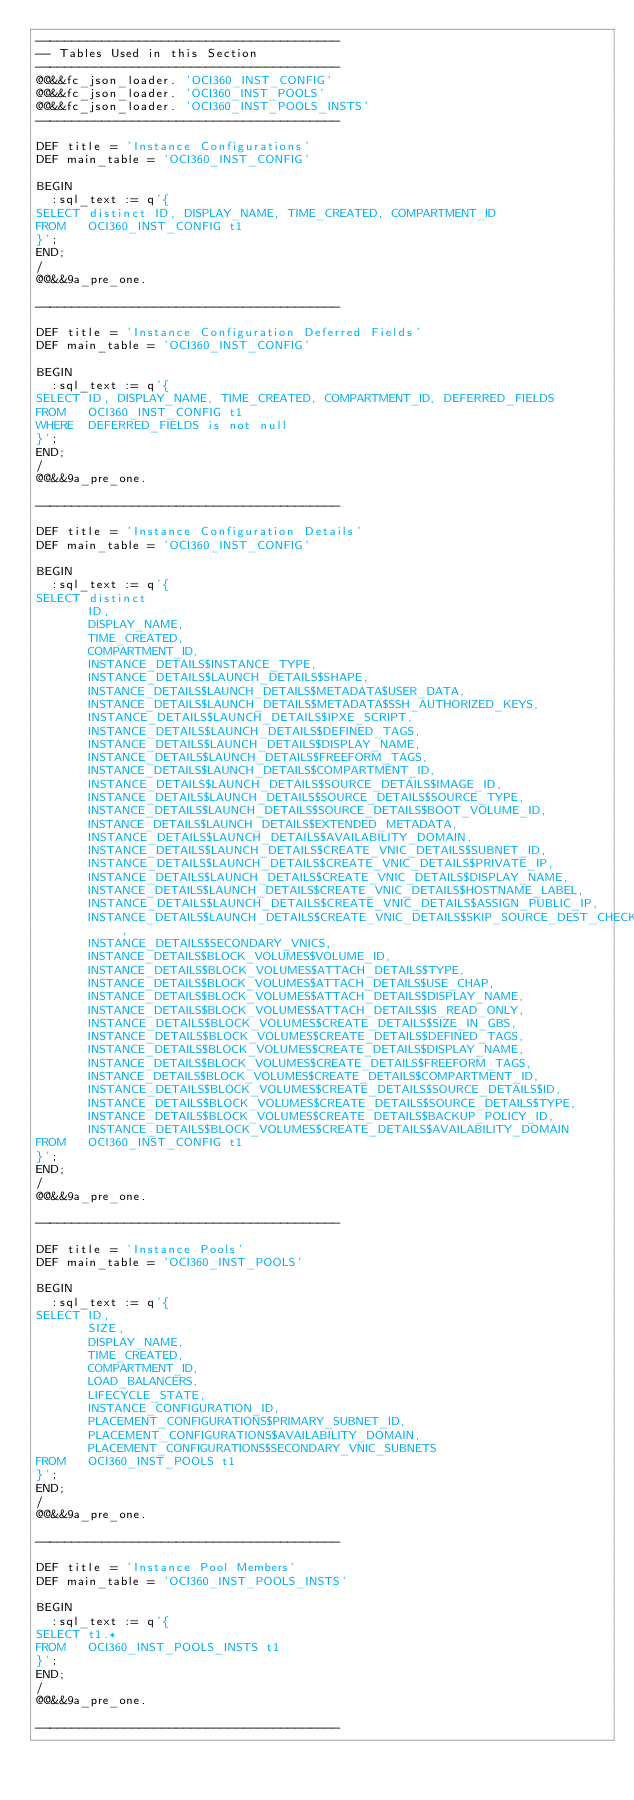Convert code to text. <code><loc_0><loc_0><loc_500><loc_500><_SQL_>-----------------------------------------
-- Tables Used in this Section
-----------------------------------------
@@&&fc_json_loader. 'OCI360_INST_CONFIG'
@@&&fc_json_loader. 'OCI360_INST_POOLS'
@@&&fc_json_loader. 'OCI360_INST_POOLS_INSTS'
-----------------------------------------

DEF title = 'Instance Configurations'
DEF main_table = 'OCI360_INST_CONFIG'

BEGIN
  :sql_text := q'{
SELECT distinct ID, DISPLAY_NAME, TIME_CREATED, COMPARTMENT_ID
FROM   OCI360_INST_CONFIG t1
}';
END;
/
@@&&9a_pre_one.

-----------------------------------------

DEF title = 'Instance Configuration Deferred Fields'
DEF main_table = 'OCI360_INST_CONFIG'

BEGIN
  :sql_text := q'{
SELECT ID, DISPLAY_NAME, TIME_CREATED, COMPARTMENT_ID, DEFERRED_FIELDS
FROM   OCI360_INST_CONFIG t1
WHERE  DEFERRED_FIELDS is not null
}';
END;
/
@@&&9a_pre_one.

-----------------------------------------

DEF title = 'Instance Configuration Details'
DEF main_table = 'OCI360_INST_CONFIG'

BEGIN
  :sql_text := q'{
SELECT distinct
       ID,
       DISPLAY_NAME,
       TIME_CREATED,
       COMPARTMENT_ID,
       INSTANCE_DETAILS$INSTANCE_TYPE,
       INSTANCE_DETAILS$LAUNCH_DETAILS$SHAPE,
       INSTANCE_DETAILS$LAUNCH_DETAILS$METADATA$USER_DATA,
       INSTANCE_DETAILS$LAUNCH_DETAILS$METADATA$SSH_AUTHORIZED_KEYS,
       INSTANCE_DETAILS$LAUNCH_DETAILS$IPXE_SCRIPT,
       INSTANCE_DETAILS$LAUNCH_DETAILS$DEFINED_TAGS,
       INSTANCE_DETAILS$LAUNCH_DETAILS$DISPLAY_NAME,
       INSTANCE_DETAILS$LAUNCH_DETAILS$FREEFORM_TAGS,
       INSTANCE_DETAILS$LAUNCH_DETAILS$COMPARTMENT_ID,
       INSTANCE_DETAILS$LAUNCH_DETAILS$SOURCE_DETAILS$IMAGE_ID,
       INSTANCE_DETAILS$LAUNCH_DETAILS$SOURCE_DETAILS$SOURCE_TYPE,
       INSTANCE_DETAILS$LAUNCH_DETAILS$SOURCE_DETAILS$BOOT_VOLUME_ID,
       INSTANCE_DETAILS$LAUNCH_DETAILS$EXTENDED_METADATA,
       INSTANCE_DETAILS$LAUNCH_DETAILS$AVAILABILITY_DOMAIN,
       INSTANCE_DETAILS$LAUNCH_DETAILS$CREATE_VNIC_DETAILS$SUBNET_ID,
       INSTANCE_DETAILS$LAUNCH_DETAILS$CREATE_VNIC_DETAILS$PRIVATE_IP,
       INSTANCE_DETAILS$LAUNCH_DETAILS$CREATE_VNIC_DETAILS$DISPLAY_NAME,
       INSTANCE_DETAILS$LAUNCH_DETAILS$CREATE_VNIC_DETAILS$HOSTNAME_LABEL,
       INSTANCE_DETAILS$LAUNCH_DETAILS$CREATE_VNIC_DETAILS$ASSIGN_PUBLIC_IP,
       INSTANCE_DETAILS$LAUNCH_DETAILS$CREATE_VNIC_DETAILS$SKIP_SOURCE_DEST_CHECK,
       INSTANCE_DETAILS$SECONDARY_VNICS,
       INSTANCE_DETAILS$BLOCK_VOLUMES$VOLUME_ID,
       INSTANCE_DETAILS$BLOCK_VOLUMES$ATTACH_DETAILS$TYPE,
       INSTANCE_DETAILS$BLOCK_VOLUMES$ATTACH_DETAILS$USE_CHAP,
       INSTANCE_DETAILS$BLOCK_VOLUMES$ATTACH_DETAILS$DISPLAY_NAME,
       INSTANCE_DETAILS$BLOCK_VOLUMES$ATTACH_DETAILS$IS_READ_ONLY,
       INSTANCE_DETAILS$BLOCK_VOLUMES$CREATE_DETAILS$SIZE_IN_GBS,
       INSTANCE_DETAILS$BLOCK_VOLUMES$CREATE_DETAILS$DEFINED_TAGS,
       INSTANCE_DETAILS$BLOCK_VOLUMES$CREATE_DETAILS$DISPLAY_NAME,
       INSTANCE_DETAILS$BLOCK_VOLUMES$CREATE_DETAILS$FREEFORM_TAGS,
       INSTANCE_DETAILS$BLOCK_VOLUMES$CREATE_DETAILS$COMPARTMENT_ID,
       INSTANCE_DETAILS$BLOCK_VOLUMES$CREATE_DETAILS$SOURCE_DETAILS$ID,
       INSTANCE_DETAILS$BLOCK_VOLUMES$CREATE_DETAILS$SOURCE_DETAILS$TYPE,
       INSTANCE_DETAILS$BLOCK_VOLUMES$CREATE_DETAILS$BACKUP_POLICY_ID,
       INSTANCE_DETAILS$BLOCK_VOLUMES$CREATE_DETAILS$AVAILABILITY_DOMAIN
FROM   OCI360_INST_CONFIG t1
}';
END;
/
@@&&9a_pre_one.

-----------------------------------------

DEF title = 'Instance Pools'
DEF main_table = 'OCI360_INST_POOLS'

BEGIN
  :sql_text := q'{
SELECT ID,
       SIZE,
       DISPLAY_NAME,
       TIME_CREATED,
       COMPARTMENT_ID,
       LOAD_BALANCERS,
       LIFECYCLE_STATE,
       INSTANCE_CONFIGURATION_ID,
       PLACEMENT_CONFIGURATIONS$PRIMARY_SUBNET_ID,
       PLACEMENT_CONFIGURATIONS$AVAILABILITY_DOMAIN,
       PLACEMENT_CONFIGURATIONS$SECONDARY_VNIC_SUBNETS
FROM   OCI360_INST_POOLS t1
}';
END;
/
@@&&9a_pre_one.

-----------------------------------------

DEF title = 'Instance Pool Members'
DEF main_table = 'OCI360_INST_POOLS_INSTS'

BEGIN
  :sql_text := q'{
SELECT t1.*
FROM   OCI360_INST_POOLS_INSTS t1
}';
END;
/
@@&&9a_pre_one.

-----------------------------------------</code> 